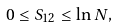Convert formula to latex. <formula><loc_0><loc_0><loc_500><loc_500>0 \leq S _ { 1 2 } \leq \ln N ,</formula> 